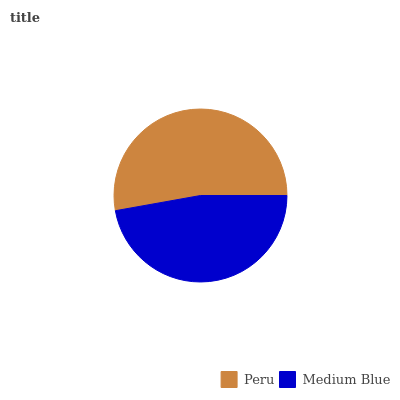Is Medium Blue the minimum?
Answer yes or no. Yes. Is Peru the maximum?
Answer yes or no. Yes. Is Medium Blue the maximum?
Answer yes or no. No. Is Peru greater than Medium Blue?
Answer yes or no. Yes. Is Medium Blue less than Peru?
Answer yes or no. Yes. Is Medium Blue greater than Peru?
Answer yes or no. No. Is Peru less than Medium Blue?
Answer yes or no. No. Is Peru the high median?
Answer yes or no. Yes. Is Medium Blue the low median?
Answer yes or no. Yes. Is Medium Blue the high median?
Answer yes or no. No. Is Peru the low median?
Answer yes or no. No. 